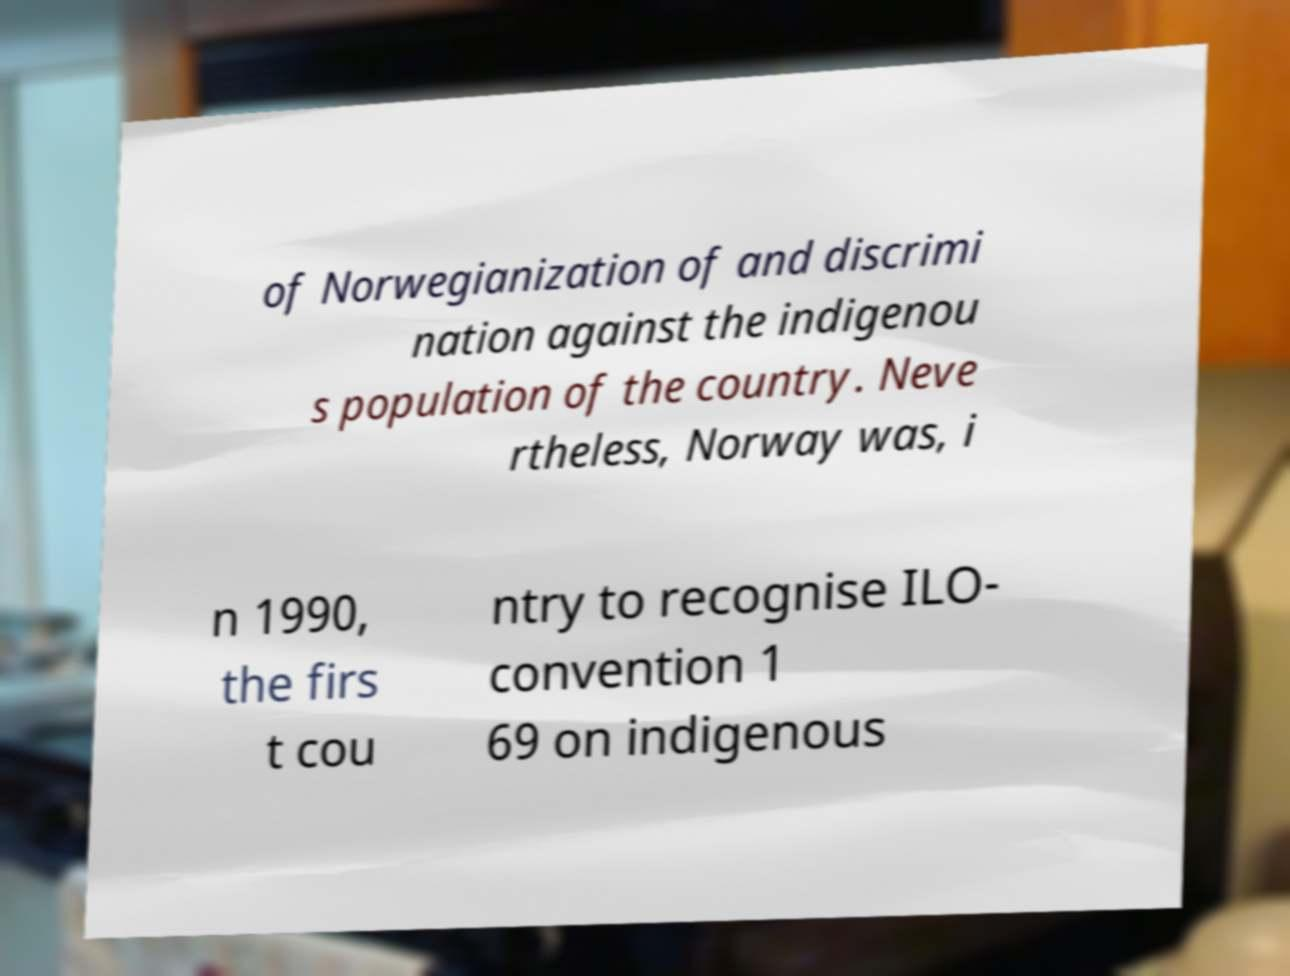Please read and relay the text visible in this image. What does it say? of Norwegianization of and discrimi nation against the indigenou s population of the country. Neve rtheless, Norway was, i n 1990, the firs t cou ntry to recognise ILO- convention 1 69 on indigenous 